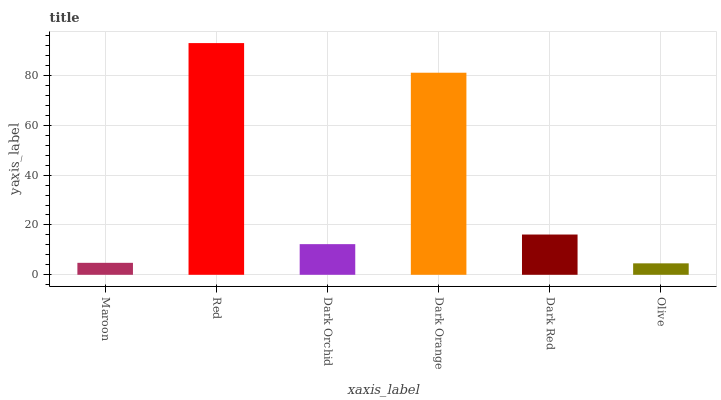Is Olive the minimum?
Answer yes or no. Yes. Is Red the maximum?
Answer yes or no. Yes. Is Dark Orchid the minimum?
Answer yes or no. No. Is Dark Orchid the maximum?
Answer yes or no. No. Is Red greater than Dark Orchid?
Answer yes or no. Yes. Is Dark Orchid less than Red?
Answer yes or no. Yes. Is Dark Orchid greater than Red?
Answer yes or no. No. Is Red less than Dark Orchid?
Answer yes or no. No. Is Dark Red the high median?
Answer yes or no. Yes. Is Dark Orchid the low median?
Answer yes or no. Yes. Is Olive the high median?
Answer yes or no. No. Is Dark Red the low median?
Answer yes or no. No. 